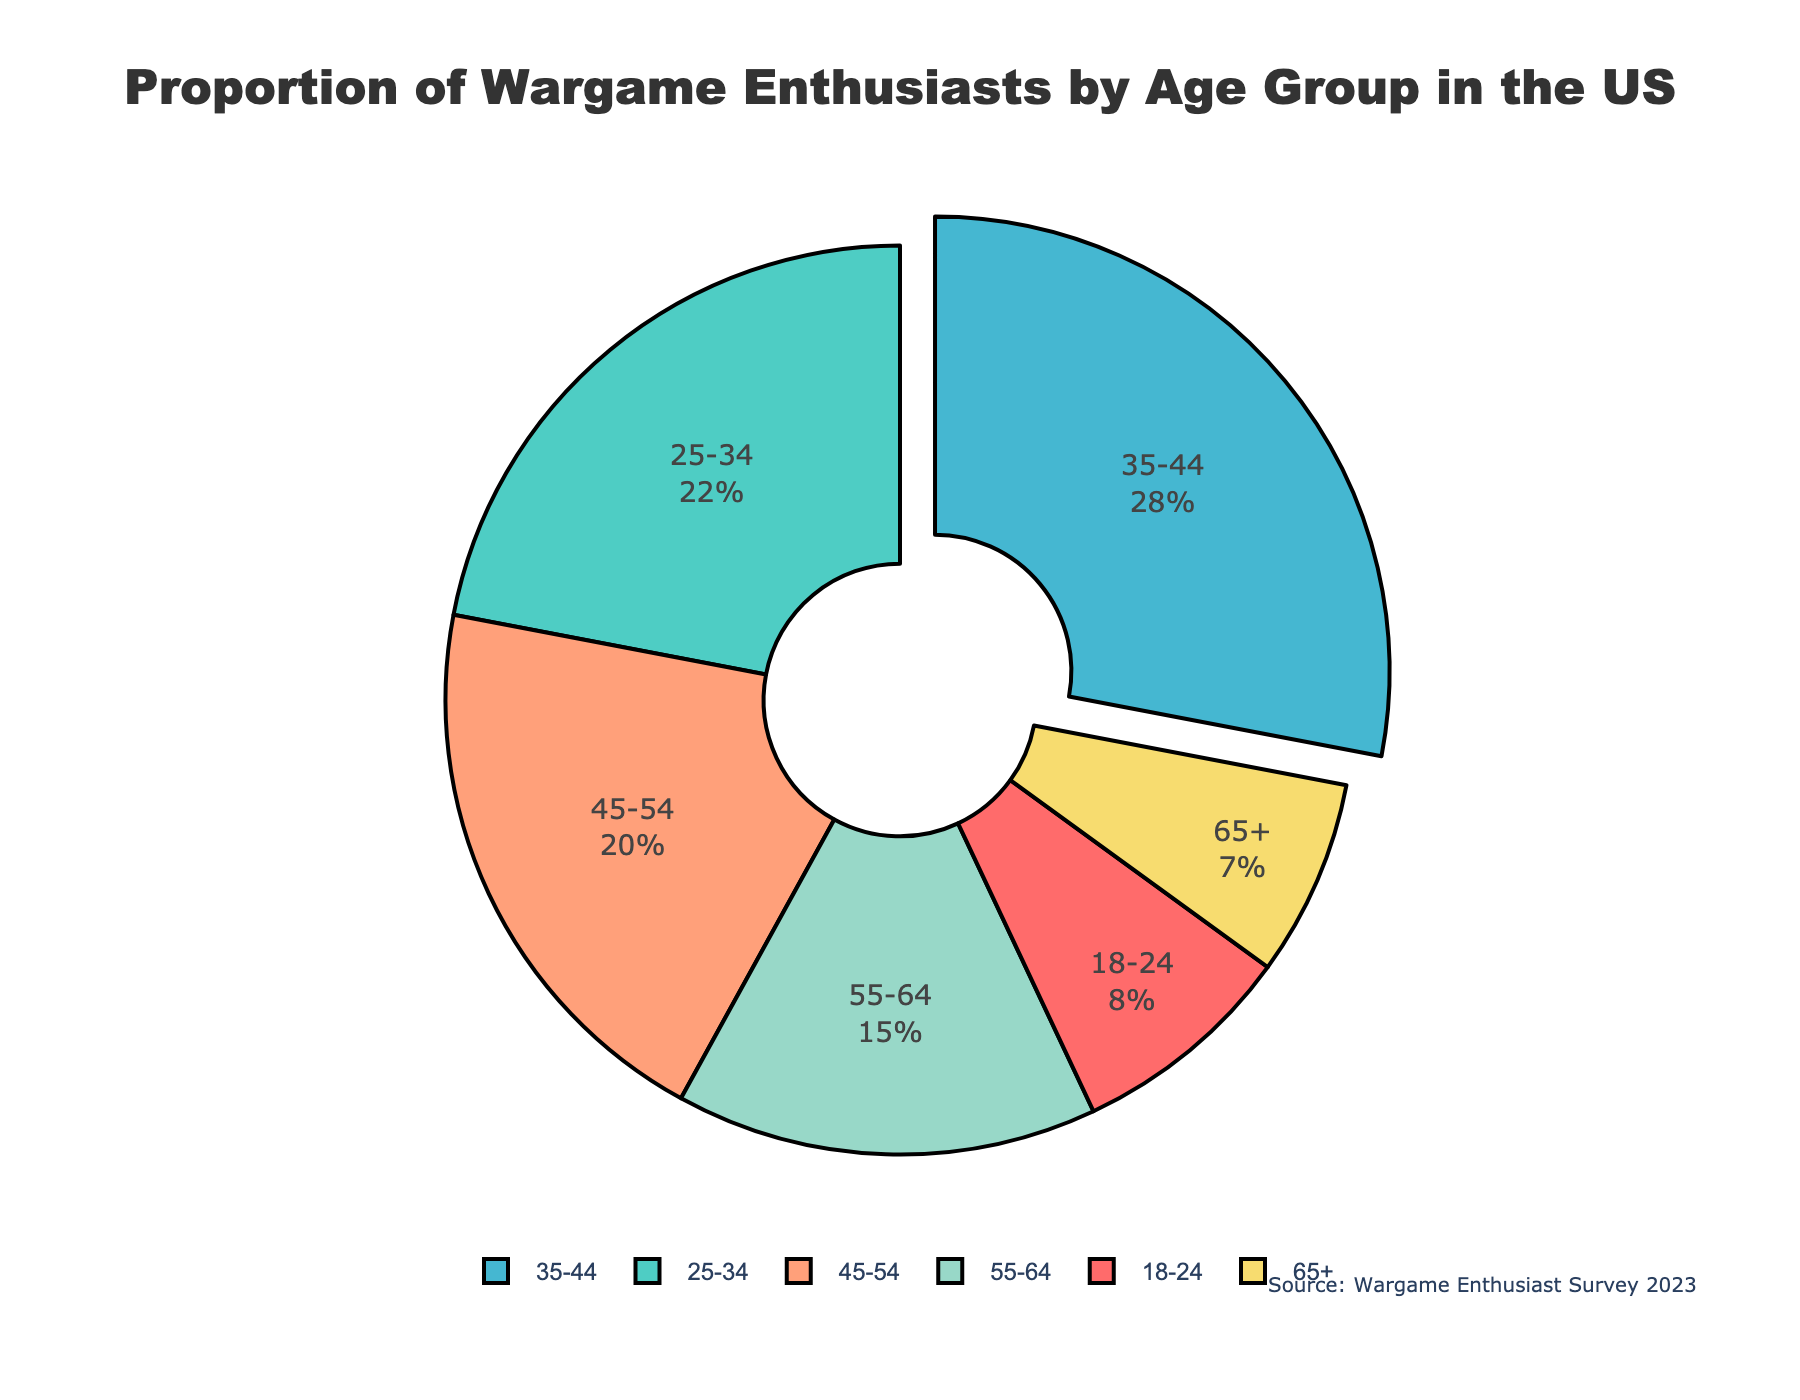What age group has the highest proportion of wargame enthusiasts? The figure shows a pie chart where each segment represents a different age group. According to the chart, the age group with the largest segment and the highest percentage is 35-44.
Answer: 35-44 What is the combined percentage of wargame enthusiasts in the 25-34 and 35-44 age groups? To find the combined percentage, add the percentages of the 25-34 age group and the 35-44 age group. According to the chart, these percentages are 22% and 28%, respectively. So, 22% + 28% = 50%.
Answer: 50% Which two age groups have the smallest proportion of wargame enthusiasts, and what is their combined percentage? The figure shows the smallest two segments representing the 18-24 age group (8%) and the 65+ age group (7%). To find their combined percentage, add these two values: 8% + 7% = 15%.
Answer: 18-24 and 65+, 15% How does the percentage of wargame enthusiasts aged 45-54 compare to those aged 55-64? The figure shows the percentage for the 45-54 age group as 20% and for the 55-64 age group as 15%. Comparing these two values, 20% is greater than 15%.
Answer: 45-54 > 55-64 What is the difference in the proportion of wargame enthusiasts between the largest and smallest age groups? The largest age group is 35-44 with 28%, and the smallest age group is 65+ with 7%. To find the difference, subtract 7% from 28%: 28% - 7% = 21%.
Answer: 21% What percentage of wargame enthusiasts are aged 55 and above? To find this, add the percentages for the 55-64 (15%) and 65+ (7%) age groups. So, 15% + 7% = 22%.
Answer: 22% Which age group is highlighted or pulled out in the chart, and why is it highlighted? The age group 35-44 is highlighted or pulled out in the pie chart. This is typically done to emphasize that this age group has the highest proportion of wargame enthusiasts.
Answer: 35-44 What colors are used to represent the 25-34 and 45-54 age groups in the pie chart? The figure uses specific colors to differentiate each age group. According to the colors depicted, the 25-34 age group is represented by green, and the 45-54 age group is represented by orange.
Answer: Green for 25-34, Orange for 45-54 Considering the chart, what might be a reason for the age group 35-44 having the highest percentage of wargame enthusiasts? This question requires interpretation beyond just the visual information, but one possible reason may be that individuals in the 35-44 age group often have stable careers and disposable income, which allows them to invest more in hobbies such as wargaming.
Answer: Interpretation needed 